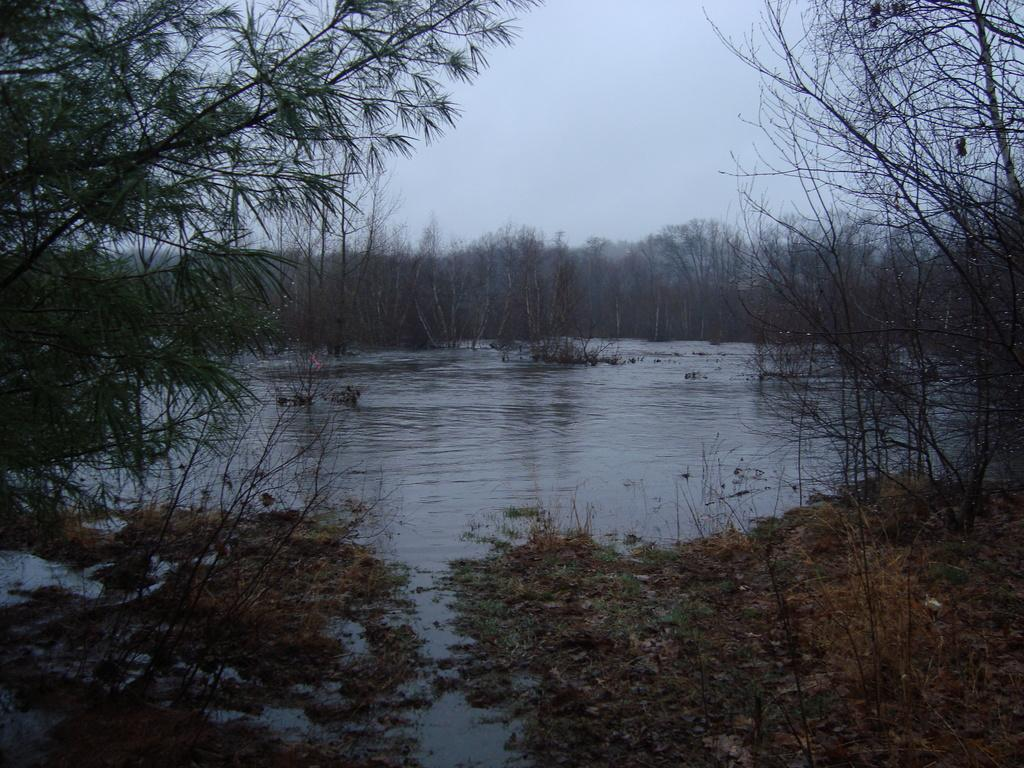What is the primary element visible in the image? There is water in the image. What types of vegetation can be seen in the image? There are plants and trees in the image. What can be seen in the background of the image? The sky is visible in the background of the image. What color is the rose in the image? There is no rose present in the image. How does the blood flow in the image? There is no blood present in the image. 